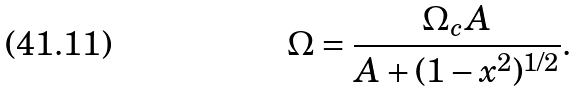<formula> <loc_0><loc_0><loc_500><loc_500>\Omega = \frac { \Omega _ { c } A } { A + ( 1 - x ^ { 2 } ) ^ { 1 / 2 } } .</formula> 